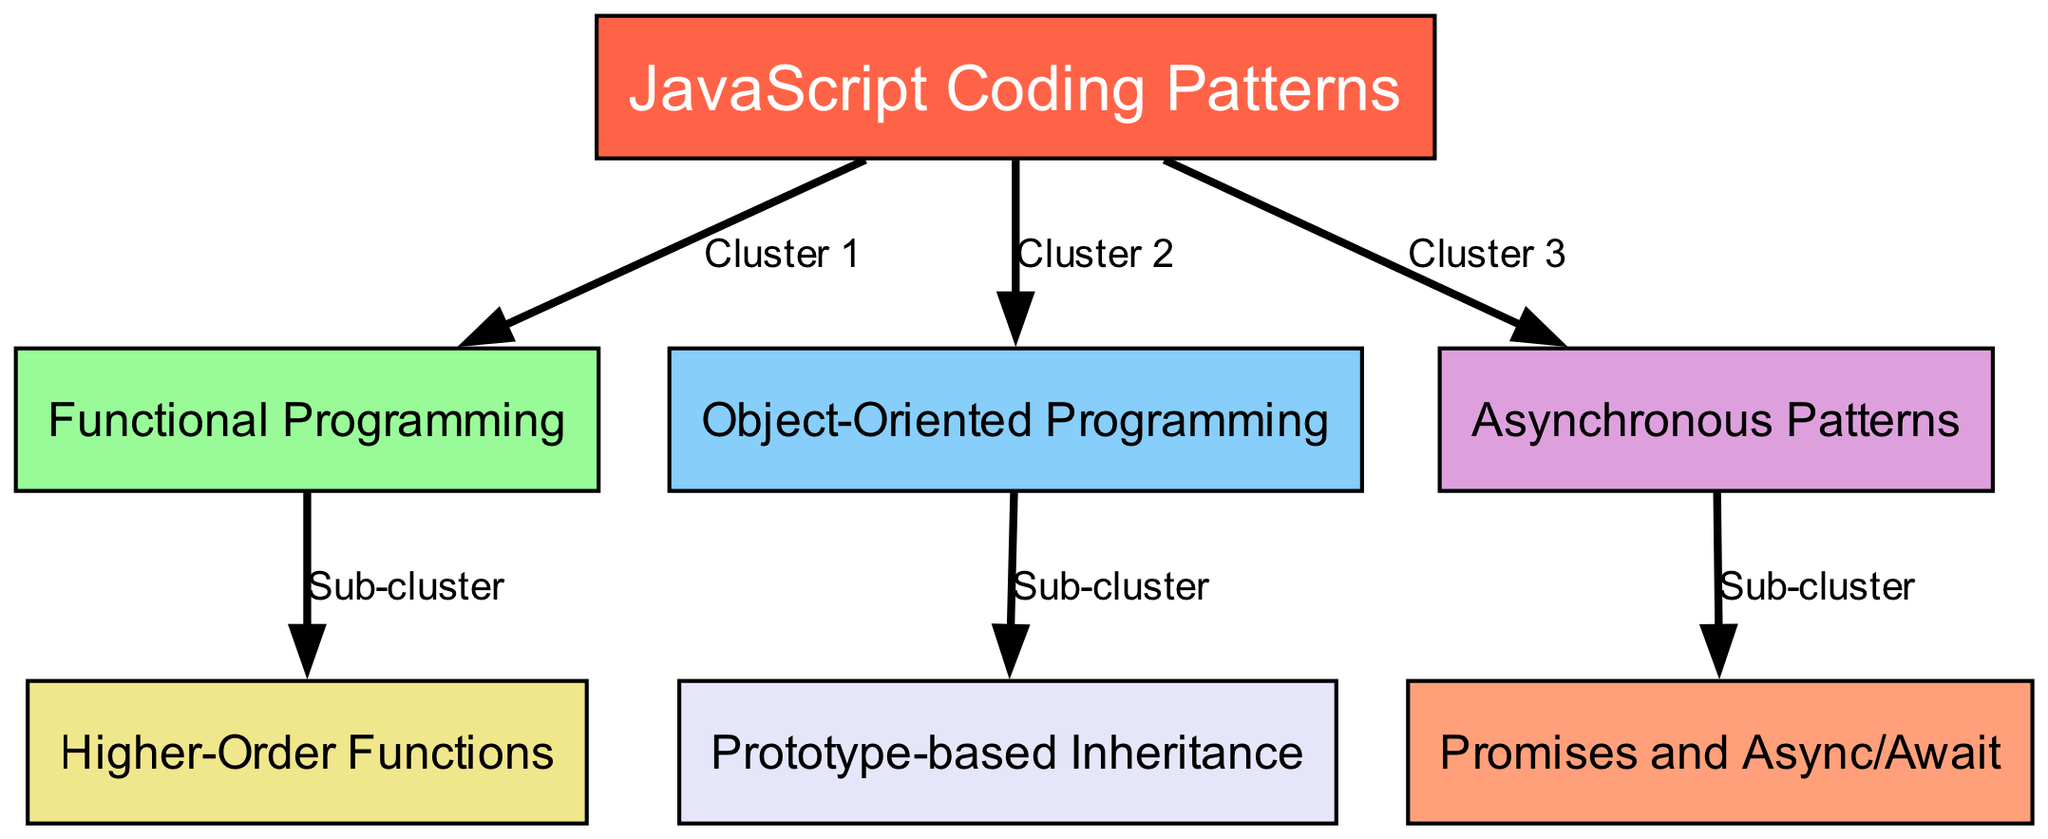What is the central node in the diagram? The central node, which represents the primary concept of the diagram, is labeled "JavaScript Coding Patterns". It connects to multiple other nodes indicating various patterns.
Answer: JavaScript Coding Patterns How many total nodes are present in the diagram? By counting the individual entries in the "nodes" section of the data, we find there are seven nodes in total.
Answer: 7 Which coding pattern is in Cluster 2? Cluster 2 is connected to the central node ("JavaScript Coding Patterns") and directly represents "Object-Oriented Programming" as indicated by the edge label and the node.
Answer: Object-Oriented Programming What pattern is represented as a sub-cluster of Functional Programming? The sub-cluster for "Functional Programming" points to "Higher-Order Functions", which means it’s a more specific node related to the broader functional programming category.
Answer: Higher-Order Functions Which node is linked to Promises and Async/Await? "Promises and Async/Await" is a node that is connected as a sub-cluster to the "Asynchronous Patterns" node, illustrating a specific implementation of asynchronous JavaScript features.
Answer: Asynchronous Patterns How many edges are depicted in the diagram? If we count the "edges" entries in the data, we find there are six connections illustrating the relationships between various coding patterns in the diagram.
Answer: 6 Which pattern is categorized under Cluster 3? Cluster 3 is associated with the pattern "Asynchronous Patterns", suggesting that it focuses on the grouping of various asynchronous coding techniques.
Answer: Asynchronous Patterns Which coding pattern utilizes prototype-based inheritance? The node labeled "Prototype-based Inheritance" is directly connected to the "Object-Oriented Programming" node, indicating its role within OOP concepts specific to JavaScript.
Answer: Object-Oriented Programming 